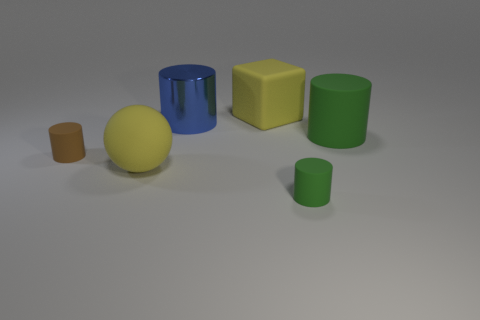Subtract all rubber cylinders. How many cylinders are left? 1 Add 1 large gray spheres. How many objects exist? 7 Subtract all purple cylinders. Subtract all purple blocks. How many cylinders are left? 4 Subtract 0 green balls. How many objects are left? 6 Subtract all cubes. How many objects are left? 5 Subtract all yellow things. Subtract all rubber cylinders. How many objects are left? 1 Add 6 green objects. How many green objects are left? 8 Add 1 green cylinders. How many green cylinders exist? 3 